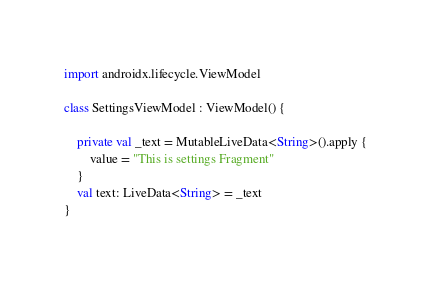Convert code to text. <code><loc_0><loc_0><loc_500><loc_500><_Kotlin_>import androidx.lifecycle.ViewModel

class SettingsViewModel : ViewModel() {

    private val _text = MutableLiveData<String>().apply {
        value = "This is settings Fragment"
    }
    val text: LiveData<String> = _text
}</code> 